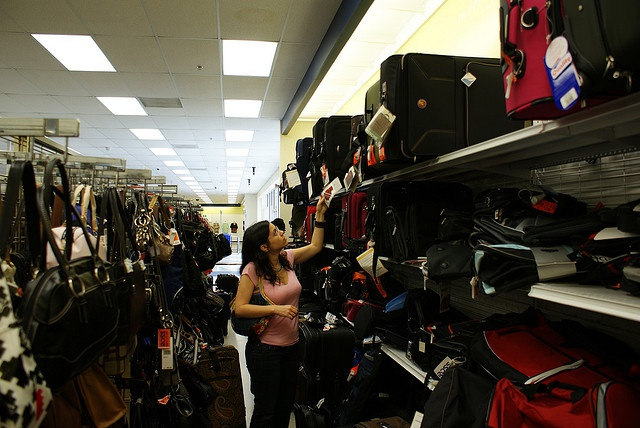Describe the objects in this image and their specific colors. I can see suitcase in darkgreen, black, maroon, and gray tones, handbag in darkgreen, black, maroon, and gray tones, handbag in darkgreen, black, maroon, and gray tones, people in darkgreen, black, maroon, and olive tones, and suitcase in darkgreen, black, olive, maroon, and khaki tones in this image. 